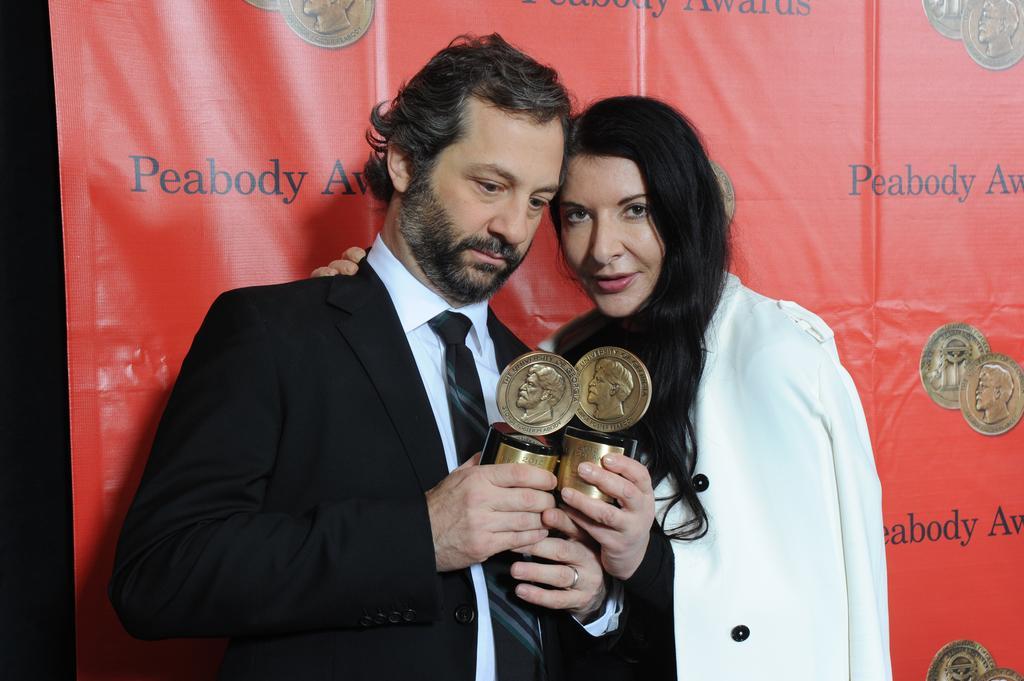How would you summarize this image in a sentence or two? In this image we can see two persons. One person is wearing coat and holding a prize in his hand. One woman is wearing white coat and holding a prize in her hand. In the background we can see a banner. 